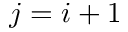Convert formula to latex. <formula><loc_0><loc_0><loc_500><loc_500>j = i + 1</formula> 